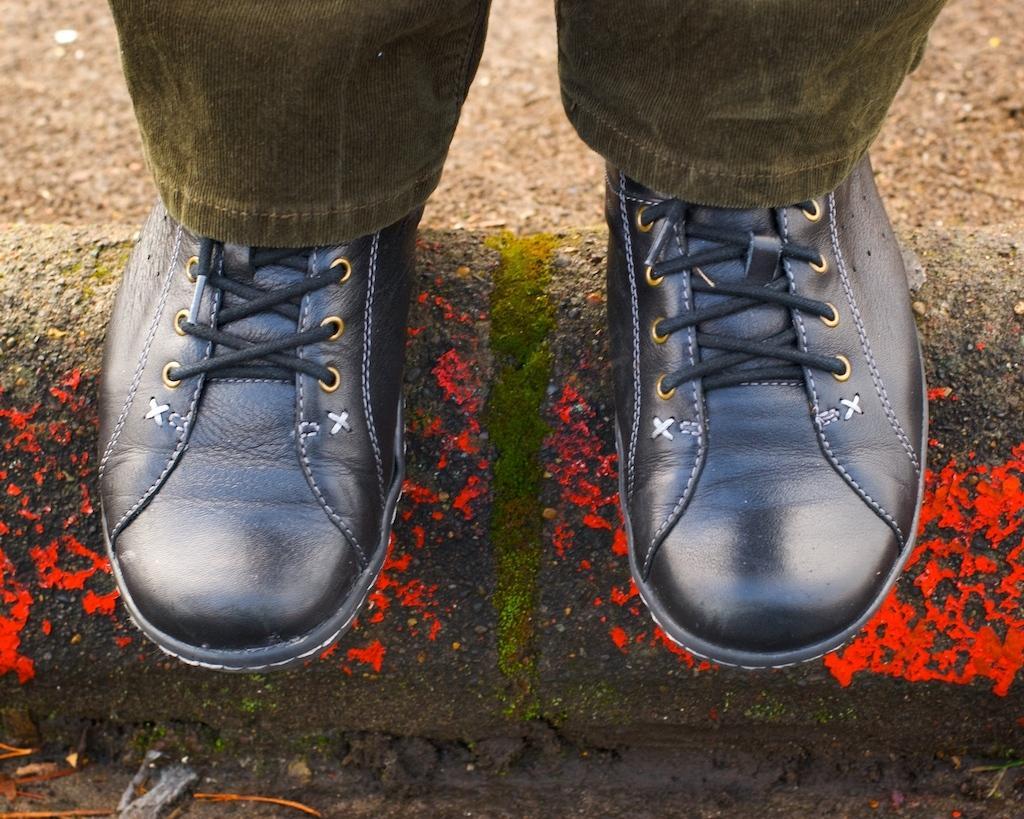Describe this image in one or two sentences. We can see grey color pant and black color shoes. On the foreground we can see mud. 